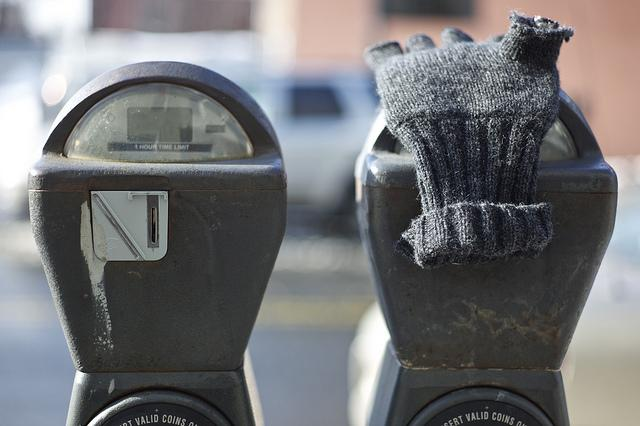What happens if you leave your car parked here an hour and a half? Please explain your reasoning. ticket. There is a parking meter. the text on it indicates that the maximum parking time is one hour. 